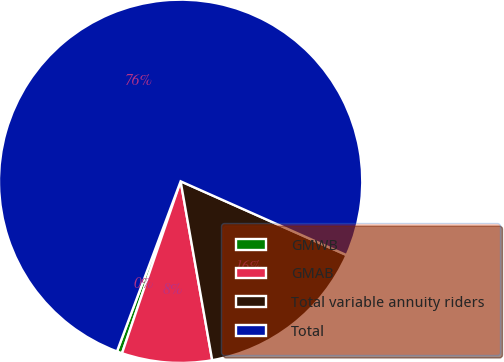Convert chart to OTSL. <chart><loc_0><loc_0><loc_500><loc_500><pie_chart><fcel>GMWB<fcel>GMAB<fcel>Total variable annuity riders<fcel>Total<nl><fcel>0.47%<fcel>8.01%<fcel>15.56%<fcel>75.96%<nl></chart> 